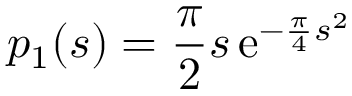Convert formula to latex. <formula><loc_0><loc_0><loc_500><loc_500>p _ { 1 } ( s ) = { \frac { \pi } { 2 } } s \, e ^ { - { \frac { \pi } { 4 } } s ^ { 2 } }</formula> 